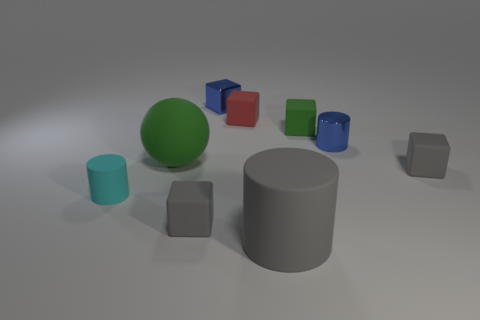Can you tell me the colors of the objects in the image? Certainly! The image features a variety of colored objects including a large green ball, a medium-sized grey cylinder, and smaller blocks in blue, red, cyan, and two additional shades of grey. Which object seems to be the largest, and what might its purpose be in this setting? The grey cylinder appears to be the largest object in this setting. Its purpose is not immediately clear without context, but it could serve a variety of functions such as a base for a structure, a placeholder for a larger scene composition, or perhaps as an object in a color and size comparison study. 